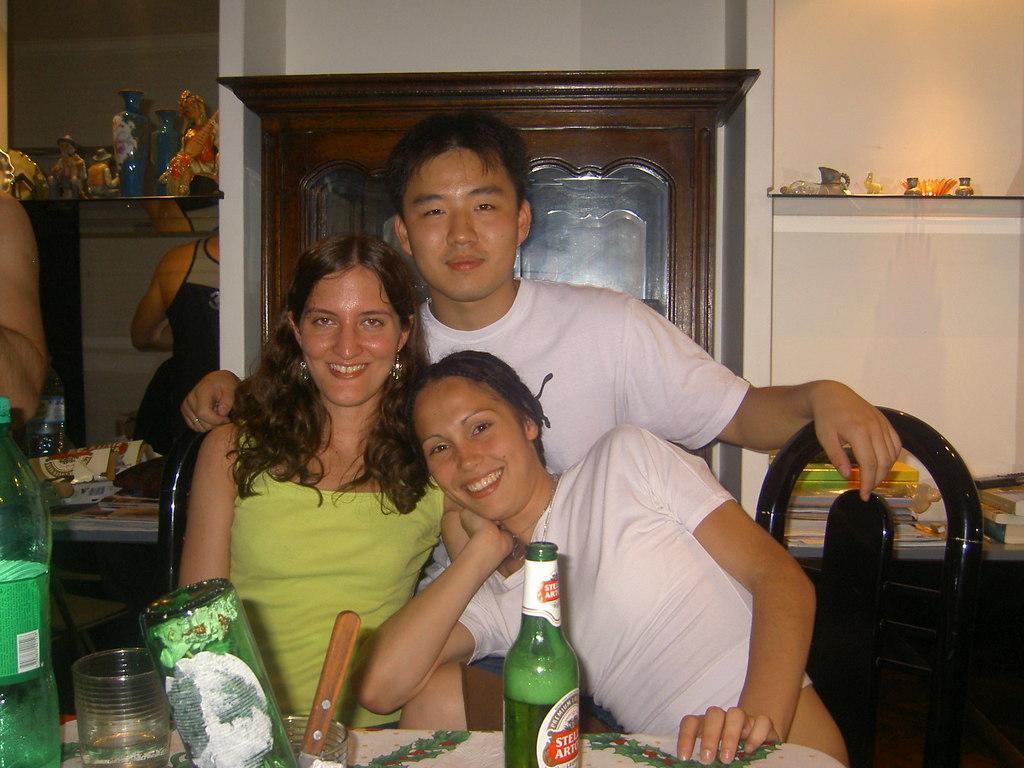Could you give a brief overview of what you see in this image? There are three people. The man with white t-shirt is standing. And the girl with the green top and other girl with the white top are sitting on the chair. In front of them there is a table. On the table there is a bottle, knife,glass. Behind them there is a cupboard. And to the right side there is a cupboard with the books. And to the left side there is a cupboard with toys. And a person we can see. 